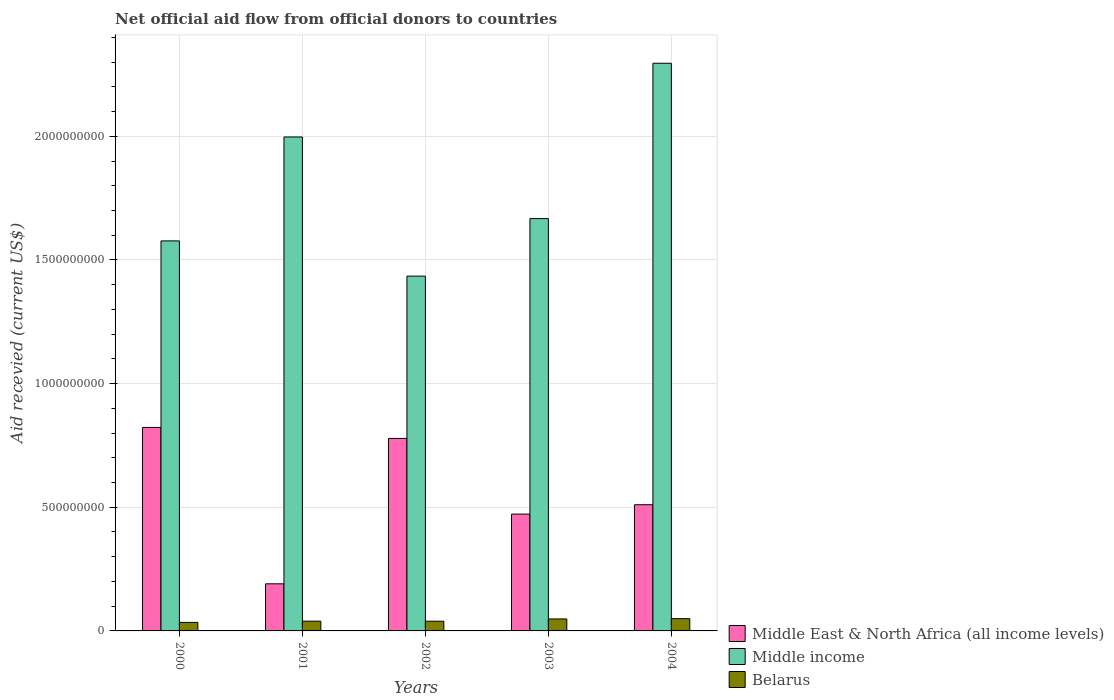How many different coloured bars are there?
Your answer should be compact. 3. Are the number of bars on each tick of the X-axis equal?
Ensure brevity in your answer.  Yes. How many bars are there on the 1st tick from the left?
Your response must be concise. 3. How many bars are there on the 5th tick from the right?
Your answer should be very brief. 3. In how many cases, is the number of bars for a given year not equal to the number of legend labels?
Keep it short and to the point. 0. What is the total aid received in Middle income in 2003?
Your answer should be very brief. 1.67e+09. Across all years, what is the maximum total aid received in Middle income?
Ensure brevity in your answer.  2.30e+09. Across all years, what is the minimum total aid received in Belarus?
Keep it short and to the point. 3.45e+07. What is the total total aid received in Middle East & North Africa (all income levels) in the graph?
Your response must be concise. 2.77e+09. What is the difference between the total aid received in Belarus in 2000 and that in 2003?
Ensure brevity in your answer.  -1.39e+07. What is the difference between the total aid received in Belarus in 2001 and the total aid received in Middle income in 2002?
Offer a terse response. -1.40e+09. What is the average total aid received in Middle income per year?
Ensure brevity in your answer.  1.79e+09. In the year 2003, what is the difference between the total aid received in Belarus and total aid received in Middle income?
Your answer should be very brief. -1.62e+09. What is the ratio of the total aid received in Middle East & North Africa (all income levels) in 2000 to that in 2003?
Your answer should be compact. 1.74. Is the total aid received in Middle East & North Africa (all income levels) in 2001 less than that in 2003?
Offer a terse response. Yes. Is the difference between the total aid received in Belarus in 2001 and 2003 greater than the difference between the total aid received in Middle income in 2001 and 2003?
Make the answer very short. No. What is the difference between the highest and the second highest total aid received in Middle East & North Africa (all income levels)?
Provide a succinct answer. 4.45e+07. What is the difference between the highest and the lowest total aid received in Middle income?
Offer a very short reply. 8.61e+08. In how many years, is the total aid received in Belarus greater than the average total aid received in Belarus taken over all years?
Offer a very short reply. 2. Is the sum of the total aid received in Belarus in 2002 and 2004 greater than the maximum total aid received in Middle income across all years?
Your answer should be very brief. No. What does the 3rd bar from the left in 2000 represents?
Make the answer very short. Belarus. What does the 3rd bar from the right in 2003 represents?
Provide a short and direct response. Middle East & North Africa (all income levels). Are all the bars in the graph horizontal?
Keep it short and to the point. No. What is the difference between two consecutive major ticks on the Y-axis?
Offer a terse response. 5.00e+08. Does the graph contain grids?
Your answer should be compact. Yes. How are the legend labels stacked?
Your response must be concise. Vertical. What is the title of the graph?
Keep it short and to the point. Net official aid flow from official donors to countries. Does "Paraguay" appear as one of the legend labels in the graph?
Keep it short and to the point. No. What is the label or title of the X-axis?
Your answer should be very brief. Years. What is the label or title of the Y-axis?
Keep it short and to the point. Aid recevied (current US$). What is the Aid recevied (current US$) of Middle East & North Africa (all income levels) in 2000?
Your answer should be compact. 8.23e+08. What is the Aid recevied (current US$) in Middle income in 2000?
Provide a short and direct response. 1.58e+09. What is the Aid recevied (current US$) of Belarus in 2000?
Your response must be concise. 3.45e+07. What is the Aid recevied (current US$) in Middle East & North Africa (all income levels) in 2001?
Your answer should be very brief. 1.90e+08. What is the Aid recevied (current US$) of Middle income in 2001?
Provide a short and direct response. 2.00e+09. What is the Aid recevied (current US$) in Belarus in 2001?
Your response must be concise. 3.94e+07. What is the Aid recevied (current US$) in Middle East & North Africa (all income levels) in 2002?
Offer a terse response. 7.78e+08. What is the Aid recevied (current US$) of Middle income in 2002?
Keep it short and to the point. 1.43e+09. What is the Aid recevied (current US$) in Belarus in 2002?
Your answer should be compact. 3.93e+07. What is the Aid recevied (current US$) of Middle East & North Africa (all income levels) in 2003?
Give a very brief answer. 4.72e+08. What is the Aid recevied (current US$) of Middle income in 2003?
Offer a very short reply. 1.67e+09. What is the Aid recevied (current US$) of Belarus in 2003?
Your response must be concise. 4.84e+07. What is the Aid recevied (current US$) in Middle East & North Africa (all income levels) in 2004?
Make the answer very short. 5.10e+08. What is the Aid recevied (current US$) in Middle income in 2004?
Provide a succinct answer. 2.30e+09. What is the Aid recevied (current US$) in Belarus in 2004?
Keep it short and to the point. 4.96e+07. Across all years, what is the maximum Aid recevied (current US$) of Middle East & North Africa (all income levels)?
Keep it short and to the point. 8.23e+08. Across all years, what is the maximum Aid recevied (current US$) in Middle income?
Your answer should be very brief. 2.30e+09. Across all years, what is the maximum Aid recevied (current US$) in Belarus?
Make the answer very short. 4.96e+07. Across all years, what is the minimum Aid recevied (current US$) of Middle East & North Africa (all income levels)?
Your answer should be compact. 1.90e+08. Across all years, what is the minimum Aid recevied (current US$) in Middle income?
Provide a short and direct response. 1.43e+09. Across all years, what is the minimum Aid recevied (current US$) of Belarus?
Provide a succinct answer. 3.45e+07. What is the total Aid recevied (current US$) of Middle East & North Africa (all income levels) in the graph?
Give a very brief answer. 2.77e+09. What is the total Aid recevied (current US$) in Middle income in the graph?
Offer a very short reply. 8.97e+09. What is the total Aid recevied (current US$) of Belarus in the graph?
Offer a very short reply. 2.11e+08. What is the difference between the Aid recevied (current US$) of Middle East & North Africa (all income levels) in 2000 and that in 2001?
Your answer should be compact. 6.32e+08. What is the difference between the Aid recevied (current US$) in Middle income in 2000 and that in 2001?
Your answer should be very brief. -4.20e+08. What is the difference between the Aid recevied (current US$) of Belarus in 2000 and that in 2001?
Keep it short and to the point. -4.96e+06. What is the difference between the Aid recevied (current US$) in Middle East & North Africa (all income levels) in 2000 and that in 2002?
Ensure brevity in your answer.  4.45e+07. What is the difference between the Aid recevied (current US$) of Middle income in 2000 and that in 2002?
Ensure brevity in your answer.  1.42e+08. What is the difference between the Aid recevied (current US$) in Belarus in 2000 and that in 2002?
Your response must be concise. -4.79e+06. What is the difference between the Aid recevied (current US$) in Middle East & North Africa (all income levels) in 2000 and that in 2003?
Offer a very short reply. 3.50e+08. What is the difference between the Aid recevied (current US$) of Middle income in 2000 and that in 2003?
Offer a very short reply. -9.02e+07. What is the difference between the Aid recevied (current US$) of Belarus in 2000 and that in 2003?
Provide a succinct answer. -1.39e+07. What is the difference between the Aid recevied (current US$) in Middle East & North Africa (all income levels) in 2000 and that in 2004?
Offer a terse response. 3.13e+08. What is the difference between the Aid recevied (current US$) of Middle income in 2000 and that in 2004?
Offer a terse response. -7.18e+08. What is the difference between the Aid recevied (current US$) of Belarus in 2000 and that in 2004?
Keep it short and to the point. -1.51e+07. What is the difference between the Aid recevied (current US$) in Middle East & North Africa (all income levels) in 2001 and that in 2002?
Provide a succinct answer. -5.88e+08. What is the difference between the Aid recevied (current US$) of Middle income in 2001 and that in 2002?
Your answer should be compact. 5.63e+08. What is the difference between the Aid recevied (current US$) in Belarus in 2001 and that in 2002?
Offer a very short reply. 1.70e+05. What is the difference between the Aid recevied (current US$) in Middle East & North Africa (all income levels) in 2001 and that in 2003?
Offer a terse response. -2.82e+08. What is the difference between the Aid recevied (current US$) in Middle income in 2001 and that in 2003?
Ensure brevity in your answer.  3.30e+08. What is the difference between the Aid recevied (current US$) in Belarus in 2001 and that in 2003?
Your answer should be compact. -8.98e+06. What is the difference between the Aid recevied (current US$) of Middle East & North Africa (all income levels) in 2001 and that in 2004?
Your response must be concise. -3.20e+08. What is the difference between the Aid recevied (current US$) in Middle income in 2001 and that in 2004?
Keep it short and to the point. -2.98e+08. What is the difference between the Aid recevied (current US$) in Belarus in 2001 and that in 2004?
Your answer should be compact. -1.01e+07. What is the difference between the Aid recevied (current US$) of Middle East & North Africa (all income levels) in 2002 and that in 2003?
Your response must be concise. 3.06e+08. What is the difference between the Aid recevied (current US$) of Middle income in 2002 and that in 2003?
Offer a very short reply. -2.33e+08. What is the difference between the Aid recevied (current US$) in Belarus in 2002 and that in 2003?
Keep it short and to the point. -9.15e+06. What is the difference between the Aid recevied (current US$) of Middle East & North Africa (all income levels) in 2002 and that in 2004?
Offer a terse response. 2.68e+08. What is the difference between the Aid recevied (current US$) in Middle income in 2002 and that in 2004?
Make the answer very short. -8.61e+08. What is the difference between the Aid recevied (current US$) in Belarus in 2002 and that in 2004?
Give a very brief answer. -1.03e+07. What is the difference between the Aid recevied (current US$) of Middle East & North Africa (all income levels) in 2003 and that in 2004?
Your answer should be compact. -3.79e+07. What is the difference between the Aid recevied (current US$) of Middle income in 2003 and that in 2004?
Give a very brief answer. -6.28e+08. What is the difference between the Aid recevied (current US$) in Belarus in 2003 and that in 2004?
Make the answer very short. -1.16e+06. What is the difference between the Aid recevied (current US$) of Middle East & North Africa (all income levels) in 2000 and the Aid recevied (current US$) of Middle income in 2001?
Offer a terse response. -1.17e+09. What is the difference between the Aid recevied (current US$) in Middle East & North Africa (all income levels) in 2000 and the Aid recevied (current US$) in Belarus in 2001?
Provide a short and direct response. 7.83e+08. What is the difference between the Aid recevied (current US$) of Middle income in 2000 and the Aid recevied (current US$) of Belarus in 2001?
Provide a short and direct response. 1.54e+09. What is the difference between the Aid recevied (current US$) in Middle East & North Africa (all income levels) in 2000 and the Aid recevied (current US$) in Middle income in 2002?
Offer a terse response. -6.12e+08. What is the difference between the Aid recevied (current US$) of Middle East & North Africa (all income levels) in 2000 and the Aid recevied (current US$) of Belarus in 2002?
Offer a terse response. 7.84e+08. What is the difference between the Aid recevied (current US$) of Middle income in 2000 and the Aid recevied (current US$) of Belarus in 2002?
Offer a terse response. 1.54e+09. What is the difference between the Aid recevied (current US$) in Middle East & North Africa (all income levels) in 2000 and the Aid recevied (current US$) in Middle income in 2003?
Provide a short and direct response. -8.44e+08. What is the difference between the Aid recevied (current US$) of Middle East & North Africa (all income levels) in 2000 and the Aid recevied (current US$) of Belarus in 2003?
Give a very brief answer. 7.74e+08. What is the difference between the Aid recevied (current US$) in Middle income in 2000 and the Aid recevied (current US$) in Belarus in 2003?
Keep it short and to the point. 1.53e+09. What is the difference between the Aid recevied (current US$) in Middle East & North Africa (all income levels) in 2000 and the Aid recevied (current US$) in Middle income in 2004?
Keep it short and to the point. -1.47e+09. What is the difference between the Aid recevied (current US$) in Middle East & North Africa (all income levels) in 2000 and the Aid recevied (current US$) in Belarus in 2004?
Make the answer very short. 7.73e+08. What is the difference between the Aid recevied (current US$) of Middle income in 2000 and the Aid recevied (current US$) of Belarus in 2004?
Ensure brevity in your answer.  1.53e+09. What is the difference between the Aid recevied (current US$) of Middle East & North Africa (all income levels) in 2001 and the Aid recevied (current US$) of Middle income in 2002?
Your answer should be very brief. -1.24e+09. What is the difference between the Aid recevied (current US$) of Middle East & North Africa (all income levels) in 2001 and the Aid recevied (current US$) of Belarus in 2002?
Keep it short and to the point. 1.51e+08. What is the difference between the Aid recevied (current US$) of Middle income in 2001 and the Aid recevied (current US$) of Belarus in 2002?
Provide a succinct answer. 1.96e+09. What is the difference between the Aid recevied (current US$) of Middle East & North Africa (all income levels) in 2001 and the Aid recevied (current US$) of Middle income in 2003?
Make the answer very short. -1.48e+09. What is the difference between the Aid recevied (current US$) of Middle East & North Africa (all income levels) in 2001 and the Aid recevied (current US$) of Belarus in 2003?
Provide a short and direct response. 1.42e+08. What is the difference between the Aid recevied (current US$) in Middle income in 2001 and the Aid recevied (current US$) in Belarus in 2003?
Your answer should be compact. 1.95e+09. What is the difference between the Aid recevied (current US$) of Middle East & North Africa (all income levels) in 2001 and the Aid recevied (current US$) of Middle income in 2004?
Keep it short and to the point. -2.10e+09. What is the difference between the Aid recevied (current US$) in Middle East & North Africa (all income levels) in 2001 and the Aid recevied (current US$) in Belarus in 2004?
Your answer should be very brief. 1.41e+08. What is the difference between the Aid recevied (current US$) in Middle income in 2001 and the Aid recevied (current US$) in Belarus in 2004?
Your answer should be very brief. 1.95e+09. What is the difference between the Aid recevied (current US$) in Middle East & North Africa (all income levels) in 2002 and the Aid recevied (current US$) in Middle income in 2003?
Give a very brief answer. -8.89e+08. What is the difference between the Aid recevied (current US$) in Middle East & North Africa (all income levels) in 2002 and the Aid recevied (current US$) in Belarus in 2003?
Make the answer very short. 7.30e+08. What is the difference between the Aid recevied (current US$) in Middle income in 2002 and the Aid recevied (current US$) in Belarus in 2003?
Ensure brevity in your answer.  1.39e+09. What is the difference between the Aid recevied (current US$) in Middle East & North Africa (all income levels) in 2002 and the Aid recevied (current US$) in Middle income in 2004?
Keep it short and to the point. -1.52e+09. What is the difference between the Aid recevied (current US$) in Middle East & North Africa (all income levels) in 2002 and the Aid recevied (current US$) in Belarus in 2004?
Your response must be concise. 7.29e+08. What is the difference between the Aid recevied (current US$) of Middle income in 2002 and the Aid recevied (current US$) of Belarus in 2004?
Make the answer very short. 1.39e+09. What is the difference between the Aid recevied (current US$) in Middle East & North Africa (all income levels) in 2003 and the Aid recevied (current US$) in Middle income in 2004?
Ensure brevity in your answer.  -1.82e+09. What is the difference between the Aid recevied (current US$) in Middle East & North Africa (all income levels) in 2003 and the Aid recevied (current US$) in Belarus in 2004?
Provide a short and direct response. 4.23e+08. What is the difference between the Aid recevied (current US$) in Middle income in 2003 and the Aid recevied (current US$) in Belarus in 2004?
Your answer should be compact. 1.62e+09. What is the average Aid recevied (current US$) of Middle East & North Africa (all income levels) per year?
Make the answer very short. 5.55e+08. What is the average Aid recevied (current US$) in Middle income per year?
Make the answer very short. 1.79e+09. What is the average Aid recevied (current US$) in Belarus per year?
Give a very brief answer. 4.22e+07. In the year 2000, what is the difference between the Aid recevied (current US$) in Middle East & North Africa (all income levels) and Aid recevied (current US$) in Middle income?
Give a very brief answer. -7.54e+08. In the year 2000, what is the difference between the Aid recevied (current US$) in Middle East & North Africa (all income levels) and Aid recevied (current US$) in Belarus?
Make the answer very short. 7.88e+08. In the year 2000, what is the difference between the Aid recevied (current US$) of Middle income and Aid recevied (current US$) of Belarus?
Offer a terse response. 1.54e+09. In the year 2001, what is the difference between the Aid recevied (current US$) in Middle East & North Africa (all income levels) and Aid recevied (current US$) in Middle income?
Give a very brief answer. -1.81e+09. In the year 2001, what is the difference between the Aid recevied (current US$) of Middle East & North Africa (all income levels) and Aid recevied (current US$) of Belarus?
Make the answer very short. 1.51e+08. In the year 2001, what is the difference between the Aid recevied (current US$) of Middle income and Aid recevied (current US$) of Belarus?
Provide a succinct answer. 1.96e+09. In the year 2002, what is the difference between the Aid recevied (current US$) of Middle East & North Africa (all income levels) and Aid recevied (current US$) of Middle income?
Your answer should be compact. -6.56e+08. In the year 2002, what is the difference between the Aid recevied (current US$) of Middle East & North Africa (all income levels) and Aid recevied (current US$) of Belarus?
Offer a terse response. 7.39e+08. In the year 2002, what is the difference between the Aid recevied (current US$) in Middle income and Aid recevied (current US$) in Belarus?
Offer a terse response. 1.40e+09. In the year 2003, what is the difference between the Aid recevied (current US$) in Middle East & North Africa (all income levels) and Aid recevied (current US$) in Middle income?
Your answer should be very brief. -1.19e+09. In the year 2003, what is the difference between the Aid recevied (current US$) in Middle East & North Africa (all income levels) and Aid recevied (current US$) in Belarus?
Provide a succinct answer. 4.24e+08. In the year 2003, what is the difference between the Aid recevied (current US$) of Middle income and Aid recevied (current US$) of Belarus?
Ensure brevity in your answer.  1.62e+09. In the year 2004, what is the difference between the Aid recevied (current US$) in Middle East & North Africa (all income levels) and Aid recevied (current US$) in Middle income?
Ensure brevity in your answer.  -1.79e+09. In the year 2004, what is the difference between the Aid recevied (current US$) in Middle East & North Africa (all income levels) and Aid recevied (current US$) in Belarus?
Your answer should be very brief. 4.61e+08. In the year 2004, what is the difference between the Aid recevied (current US$) in Middle income and Aid recevied (current US$) in Belarus?
Keep it short and to the point. 2.25e+09. What is the ratio of the Aid recevied (current US$) of Middle East & North Africa (all income levels) in 2000 to that in 2001?
Provide a short and direct response. 4.32. What is the ratio of the Aid recevied (current US$) in Middle income in 2000 to that in 2001?
Your response must be concise. 0.79. What is the ratio of the Aid recevied (current US$) in Belarus in 2000 to that in 2001?
Make the answer very short. 0.87. What is the ratio of the Aid recevied (current US$) of Middle East & North Africa (all income levels) in 2000 to that in 2002?
Your answer should be compact. 1.06. What is the ratio of the Aid recevied (current US$) of Middle income in 2000 to that in 2002?
Ensure brevity in your answer.  1.1. What is the ratio of the Aid recevied (current US$) in Belarus in 2000 to that in 2002?
Ensure brevity in your answer.  0.88. What is the ratio of the Aid recevied (current US$) of Middle East & North Africa (all income levels) in 2000 to that in 2003?
Offer a terse response. 1.74. What is the ratio of the Aid recevied (current US$) in Middle income in 2000 to that in 2003?
Your response must be concise. 0.95. What is the ratio of the Aid recevied (current US$) of Belarus in 2000 to that in 2003?
Your answer should be compact. 0.71. What is the ratio of the Aid recevied (current US$) of Middle East & North Africa (all income levels) in 2000 to that in 2004?
Offer a very short reply. 1.61. What is the ratio of the Aid recevied (current US$) in Middle income in 2000 to that in 2004?
Provide a succinct answer. 0.69. What is the ratio of the Aid recevied (current US$) in Belarus in 2000 to that in 2004?
Your answer should be very brief. 0.7. What is the ratio of the Aid recevied (current US$) in Middle East & North Africa (all income levels) in 2001 to that in 2002?
Keep it short and to the point. 0.24. What is the ratio of the Aid recevied (current US$) of Middle income in 2001 to that in 2002?
Give a very brief answer. 1.39. What is the ratio of the Aid recevied (current US$) in Belarus in 2001 to that in 2002?
Provide a succinct answer. 1. What is the ratio of the Aid recevied (current US$) in Middle East & North Africa (all income levels) in 2001 to that in 2003?
Provide a short and direct response. 0.4. What is the ratio of the Aid recevied (current US$) of Middle income in 2001 to that in 2003?
Your response must be concise. 1.2. What is the ratio of the Aid recevied (current US$) in Belarus in 2001 to that in 2003?
Ensure brevity in your answer.  0.81. What is the ratio of the Aid recevied (current US$) in Middle East & North Africa (all income levels) in 2001 to that in 2004?
Provide a short and direct response. 0.37. What is the ratio of the Aid recevied (current US$) in Middle income in 2001 to that in 2004?
Ensure brevity in your answer.  0.87. What is the ratio of the Aid recevied (current US$) of Belarus in 2001 to that in 2004?
Your answer should be compact. 0.8. What is the ratio of the Aid recevied (current US$) in Middle East & North Africa (all income levels) in 2002 to that in 2003?
Make the answer very short. 1.65. What is the ratio of the Aid recevied (current US$) in Middle income in 2002 to that in 2003?
Offer a very short reply. 0.86. What is the ratio of the Aid recevied (current US$) of Belarus in 2002 to that in 2003?
Provide a succinct answer. 0.81. What is the ratio of the Aid recevied (current US$) of Middle East & North Africa (all income levels) in 2002 to that in 2004?
Make the answer very short. 1.53. What is the ratio of the Aid recevied (current US$) in Middle income in 2002 to that in 2004?
Offer a terse response. 0.62. What is the ratio of the Aid recevied (current US$) in Belarus in 2002 to that in 2004?
Offer a very short reply. 0.79. What is the ratio of the Aid recevied (current US$) of Middle East & North Africa (all income levels) in 2003 to that in 2004?
Keep it short and to the point. 0.93. What is the ratio of the Aid recevied (current US$) in Middle income in 2003 to that in 2004?
Make the answer very short. 0.73. What is the ratio of the Aid recevied (current US$) in Belarus in 2003 to that in 2004?
Offer a terse response. 0.98. What is the difference between the highest and the second highest Aid recevied (current US$) in Middle East & North Africa (all income levels)?
Ensure brevity in your answer.  4.45e+07. What is the difference between the highest and the second highest Aid recevied (current US$) in Middle income?
Your response must be concise. 2.98e+08. What is the difference between the highest and the second highest Aid recevied (current US$) of Belarus?
Your answer should be very brief. 1.16e+06. What is the difference between the highest and the lowest Aid recevied (current US$) in Middle East & North Africa (all income levels)?
Give a very brief answer. 6.32e+08. What is the difference between the highest and the lowest Aid recevied (current US$) in Middle income?
Offer a very short reply. 8.61e+08. What is the difference between the highest and the lowest Aid recevied (current US$) of Belarus?
Give a very brief answer. 1.51e+07. 